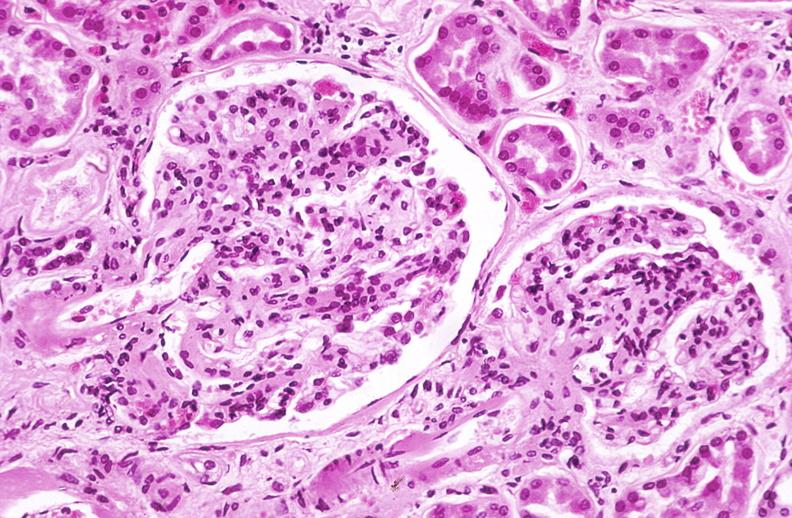where is this?
Answer the question using a single word or phrase. Urinary 